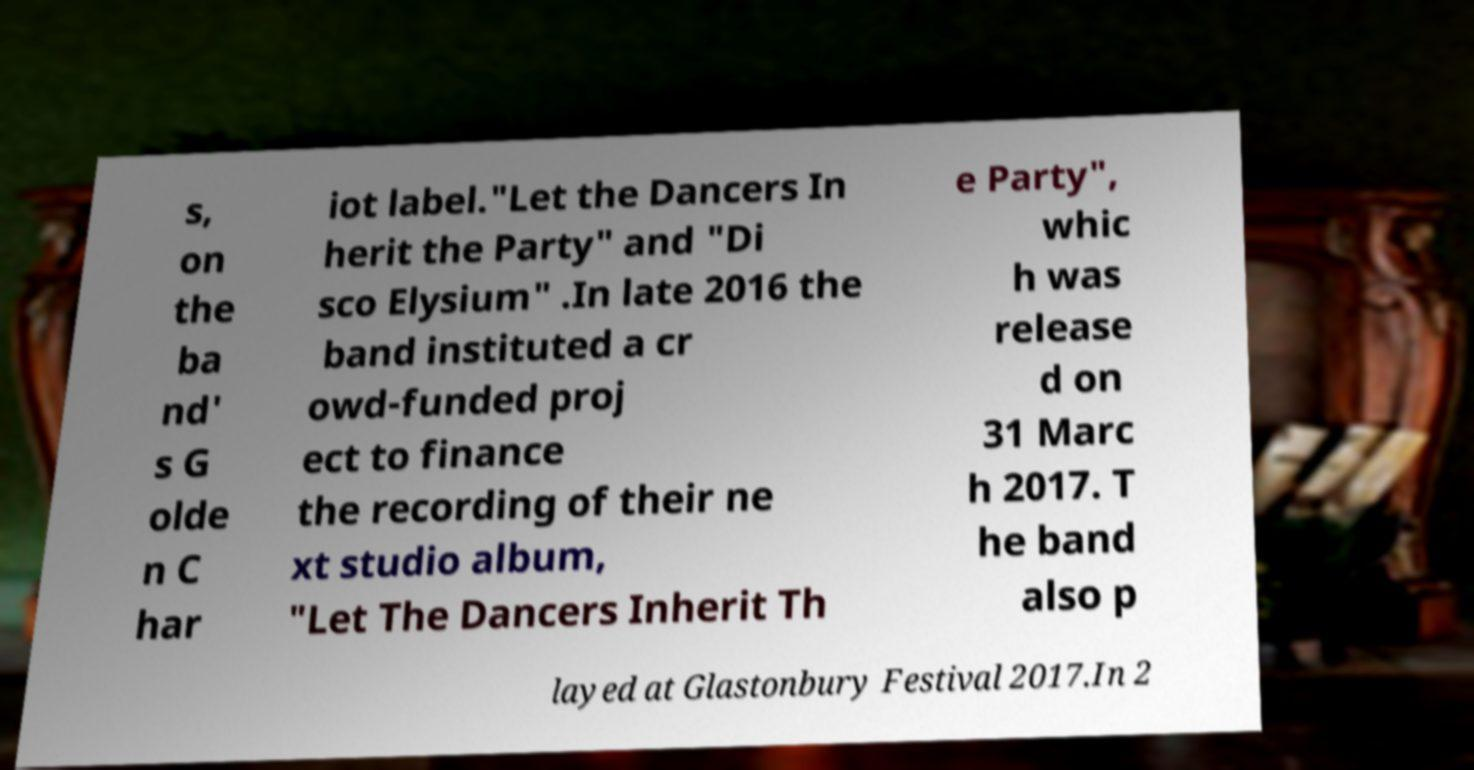For documentation purposes, I need the text within this image transcribed. Could you provide that? s, on the ba nd' s G olde n C har iot label."Let the Dancers In herit the Party" and "Di sco Elysium" .In late 2016 the band instituted a cr owd-funded proj ect to finance the recording of their ne xt studio album, "Let The Dancers Inherit Th e Party", whic h was release d on 31 Marc h 2017. T he band also p layed at Glastonbury Festival 2017.In 2 